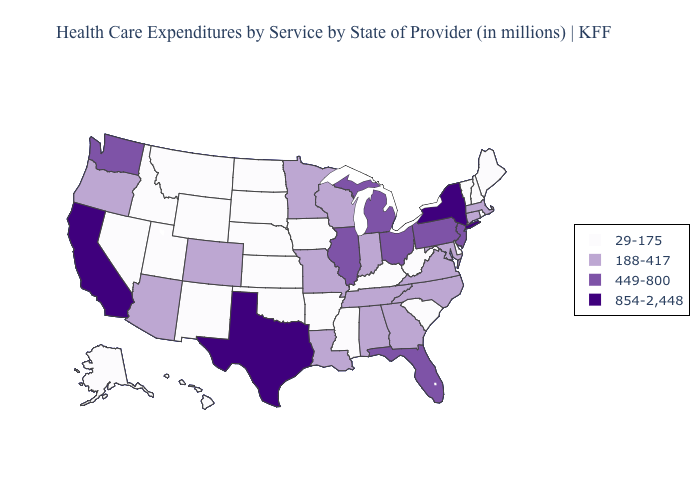What is the value of Florida?
Answer briefly. 449-800. What is the value of Utah?
Short answer required. 29-175. Name the states that have a value in the range 854-2,448?
Keep it brief. California, New York, Texas. What is the highest value in the South ?
Answer briefly. 854-2,448. What is the value of Louisiana?
Be succinct. 188-417. Does Oklahoma have the same value as Kansas?
Write a very short answer. Yes. Which states hav the highest value in the West?
Concise answer only. California. Does Kentucky have the lowest value in the South?
Give a very brief answer. Yes. Among the states that border Maryland , does Pennsylvania have the highest value?
Write a very short answer. Yes. Name the states that have a value in the range 29-175?
Answer briefly. Alaska, Arkansas, Delaware, Hawaii, Idaho, Iowa, Kansas, Kentucky, Maine, Mississippi, Montana, Nebraska, Nevada, New Hampshire, New Mexico, North Dakota, Oklahoma, Rhode Island, South Carolina, South Dakota, Utah, Vermont, West Virginia, Wyoming. Which states have the lowest value in the MidWest?
Answer briefly. Iowa, Kansas, Nebraska, North Dakota, South Dakota. What is the lowest value in the MidWest?
Concise answer only. 29-175. Does Hawaii have a lower value than New Hampshire?
Short answer required. No. Does Michigan have the same value as Florida?
Quick response, please. Yes. What is the highest value in the USA?
Keep it brief. 854-2,448. 